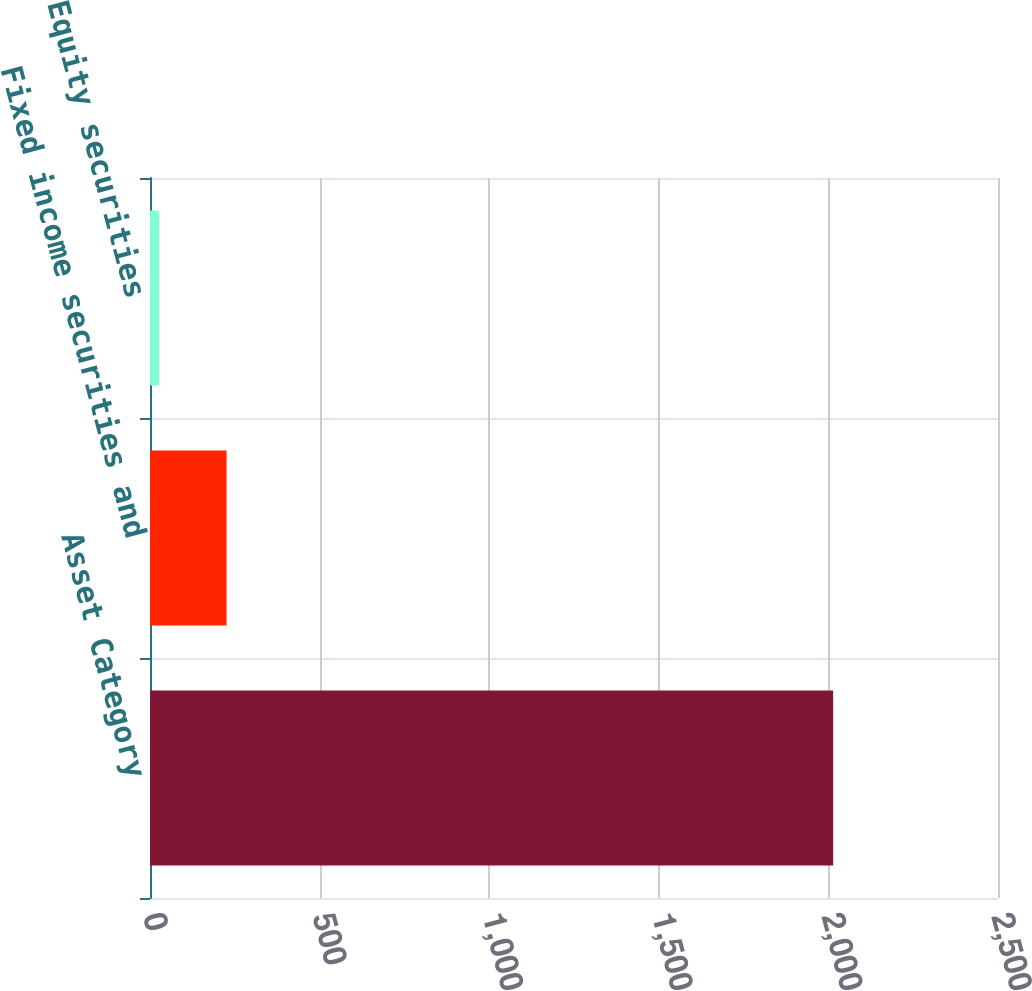Convert chart to OTSL. <chart><loc_0><loc_0><loc_500><loc_500><bar_chart><fcel>Asset Category<fcel>Fixed income securities and<fcel>Equity securities<nl><fcel>2014<fcel>225.7<fcel>27<nl></chart> 